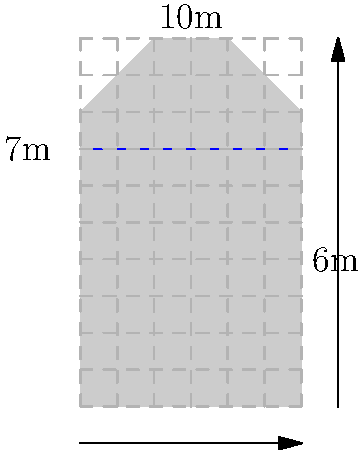In a cinematic exploration of environmental engineering, you're analyzing a scene featuring a dam. The cross-sectional diagram of the dam is shown above. If the water level is at 7 meters and the width of the dam is 6 meters, calculate the volumetric flow rate through the dam if the velocity of water passing through is 0.5 m/s. Assume the dam's length perpendicular to the cross-section is 100 meters. To solve this problem, we'll follow these steps:

1) First, we need to calculate the cross-sectional area of water passing through the dam. From the diagram, we can see that the water forms a rectangle.

2) The height of this rectangle is 7 meters (water level), and the width is 6 meters (width of the dam).

3) The area of this rectangle is:
   $$A = 7 \text{ m} \times 6 \text{ m} = 42 \text{ m}^2$$

4) Now, we need to consider the length of the dam perpendicular to this cross-section, which is given as 100 meters. This forms a volumetric space through which water is flowing.

5) The volumetric flow rate is calculated using the formula:
   $$Q = A \times v$$
   Where:
   $Q$ is the volumetric flow rate
   $A$ is the cross-sectional area
   $v$ is the velocity of water

6) We have:
   $A = 42 \text{ m}^2$
   $v = 0.5 \text{ m/s}$

7) Plugging these into our formula:
   $$Q = 42 \text{ m}^2 \times 0.5 \text{ m/s} = 21 \text{ m}^3/\text{s}$$

Therefore, the volumetric flow rate through the dam is 21 cubic meters per second.
Answer: 21 m³/s 